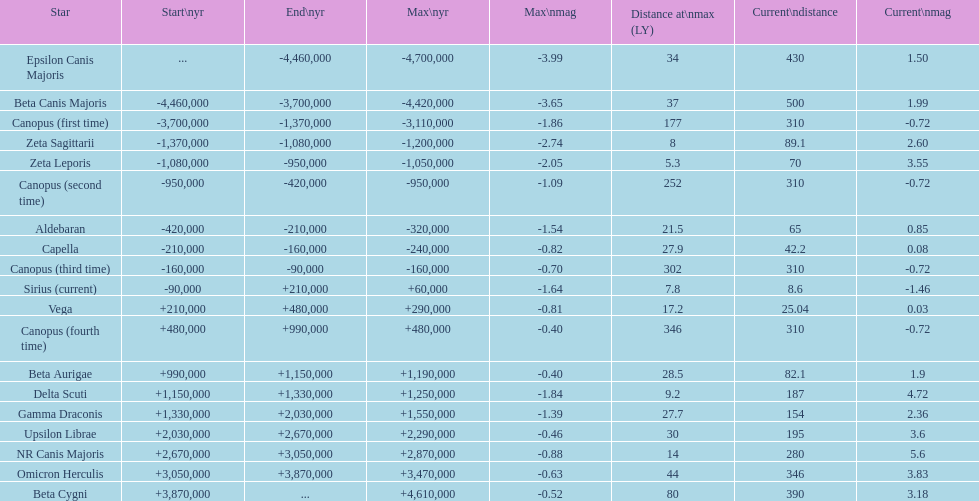Is capella's current magnitude more than vega's current magnitude? Yes. 